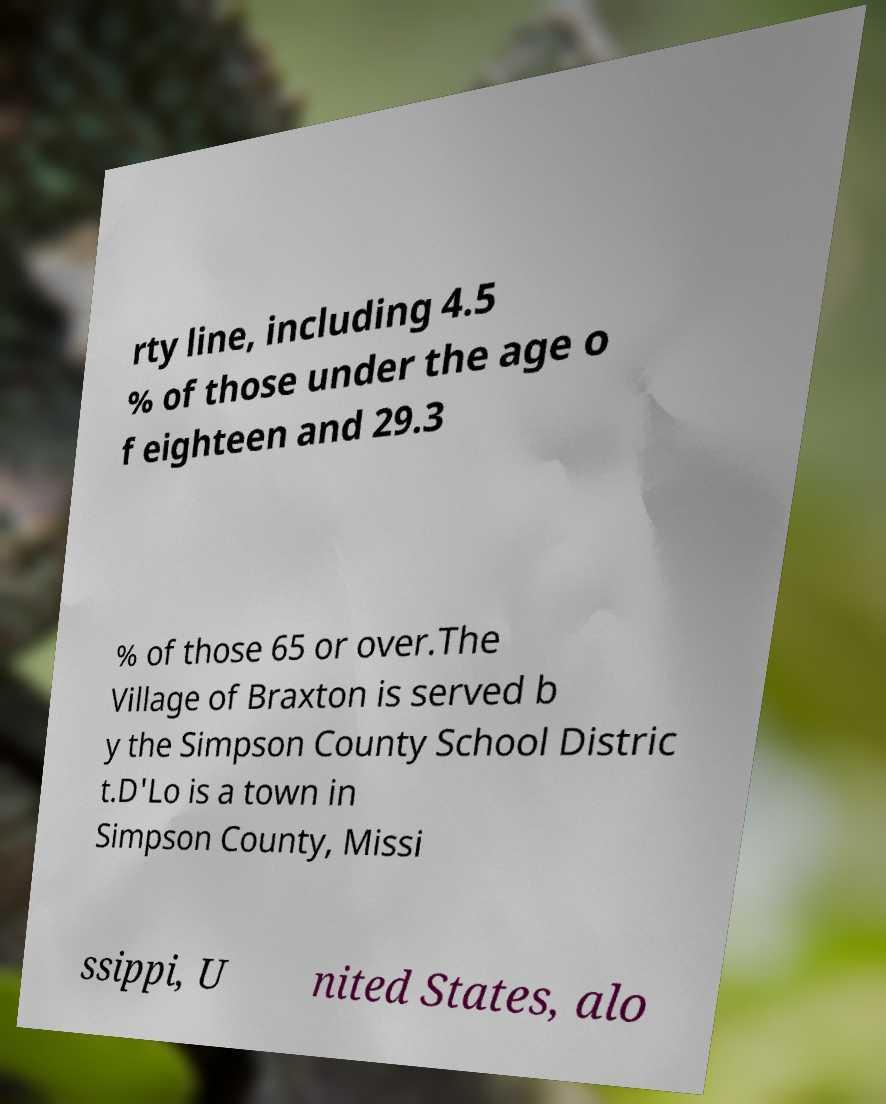Can you accurately transcribe the text from the provided image for me? rty line, including 4.5 % of those under the age o f eighteen and 29.3 % of those 65 or over.The Village of Braxton is served b y the Simpson County School Distric t.D'Lo is a town in Simpson County, Missi ssippi, U nited States, alo 